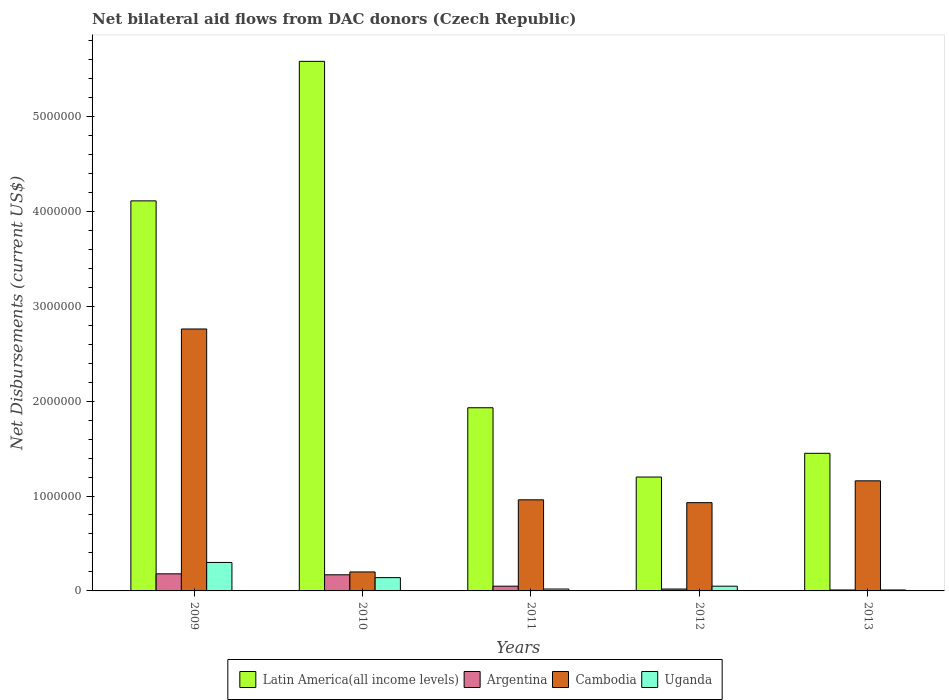How many different coloured bars are there?
Ensure brevity in your answer.  4. Are the number of bars per tick equal to the number of legend labels?
Provide a succinct answer. Yes. How many bars are there on the 5th tick from the right?
Offer a very short reply. 4. What is the label of the 2nd group of bars from the left?
Your response must be concise. 2010. What is the net bilateral aid flows in Argentina in 2011?
Offer a terse response. 5.00e+04. Across all years, what is the maximum net bilateral aid flows in Argentina?
Keep it short and to the point. 1.80e+05. Across all years, what is the minimum net bilateral aid flows in Latin America(all income levels)?
Offer a terse response. 1.20e+06. In which year was the net bilateral aid flows in Uganda maximum?
Make the answer very short. 2009. In which year was the net bilateral aid flows in Uganda minimum?
Ensure brevity in your answer.  2013. What is the total net bilateral aid flows in Cambodia in the graph?
Provide a short and direct response. 6.01e+06. What is the difference between the net bilateral aid flows in Argentina in 2009 and that in 2010?
Your answer should be compact. 10000. What is the difference between the net bilateral aid flows in Uganda in 2011 and the net bilateral aid flows in Cambodia in 2012?
Give a very brief answer. -9.10e+05. What is the average net bilateral aid flows in Argentina per year?
Offer a terse response. 8.60e+04. In the year 2009, what is the difference between the net bilateral aid flows in Uganda and net bilateral aid flows in Latin America(all income levels)?
Keep it short and to the point. -3.81e+06. What is the ratio of the net bilateral aid flows in Cambodia in 2010 to that in 2013?
Your response must be concise. 0.17. Is the net bilateral aid flows in Cambodia in 2011 less than that in 2012?
Keep it short and to the point. No. Is the difference between the net bilateral aid flows in Uganda in 2011 and 2013 greater than the difference between the net bilateral aid flows in Latin America(all income levels) in 2011 and 2013?
Provide a short and direct response. No. What is the difference between the highest and the second highest net bilateral aid flows in Cambodia?
Keep it short and to the point. 1.60e+06. What is the difference between the highest and the lowest net bilateral aid flows in Cambodia?
Provide a succinct answer. 2.56e+06. In how many years, is the net bilateral aid flows in Uganda greater than the average net bilateral aid flows in Uganda taken over all years?
Give a very brief answer. 2. Is it the case that in every year, the sum of the net bilateral aid flows in Uganda and net bilateral aid flows in Cambodia is greater than the sum of net bilateral aid flows in Latin America(all income levels) and net bilateral aid flows in Argentina?
Give a very brief answer. No. What does the 1st bar from the left in 2012 represents?
Offer a terse response. Latin America(all income levels). What does the 2nd bar from the right in 2009 represents?
Your answer should be compact. Cambodia. How many years are there in the graph?
Your answer should be compact. 5. Are the values on the major ticks of Y-axis written in scientific E-notation?
Give a very brief answer. No. Where does the legend appear in the graph?
Your answer should be very brief. Bottom center. How are the legend labels stacked?
Offer a terse response. Horizontal. What is the title of the graph?
Offer a very short reply. Net bilateral aid flows from DAC donors (Czech Republic). What is the label or title of the X-axis?
Make the answer very short. Years. What is the label or title of the Y-axis?
Your answer should be very brief. Net Disbursements (current US$). What is the Net Disbursements (current US$) of Latin America(all income levels) in 2009?
Your answer should be compact. 4.11e+06. What is the Net Disbursements (current US$) of Cambodia in 2009?
Provide a short and direct response. 2.76e+06. What is the Net Disbursements (current US$) in Uganda in 2009?
Offer a terse response. 3.00e+05. What is the Net Disbursements (current US$) of Latin America(all income levels) in 2010?
Make the answer very short. 5.58e+06. What is the Net Disbursements (current US$) of Argentina in 2010?
Offer a terse response. 1.70e+05. What is the Net Disbursements (current US$) in Latin America(all income levels) in 2011?
Give a very brief answer. 1.93e+06. What is the Net Disbursements (current US$) in Cambodia in 2011?
Make the answer very short. 9.60e+05. What is the Net Disbursements (current US$) in Latin America(all income levels) in 2012?
Give a very brief answer. 1.20e+06. What is the Net Disbursements (current US$) in Cambodia in 2012?
Make the answer very short. 9.30e+05. What is the Net Disbursements (current US$) of Uganda in 2012?
Give a very brief answer. 5.00e+04. What is the Net Disbursements (current US$) of Latin America(all income levels) in 2013?
Make the answer very short. 1.45e+06. What is the Net Disbursements (current US$) of Cambodia in 2013?
Make the answer very short. 1.16e+06. What is the Net Disbursements (current US$) in Uganda in 2013?
Make the answer very short. 10000. Across all years, what is the maximum Net Disbursements (current US$) of Latin America(all income levels)?
Provide a succinct answer. 5.58e+06. Across all years, what is the maximum Net Disbursements (current US$) of Argentina?
Offer a terse response. 1.80e+05. Across all years, what is the maximum Net Disbursements (current US$) of Cambodia?
Offer a very short reply. 2.76e+06. Across all years, what is the maximum Net Disbursements (current US$) in Uganda?
Offer a very short reply. 3.00e+05. Across all years, what is the minimum Net Disbursements (current US$) in Latin America(all income levels)?
Offer a very short reply. 1.20e+06. Across all years, what is the minimum Net Disbursements (current US$) in Argentina?
Provide a short and direct response. 10000. Across all years, what is the minimum Net Disbursements (current US$) in Uganda?
Make the answer very short. 10000. What is the total Net Disbursements (current US$) of Latin America(all income levels) in the graph?
Offer a very short reply. 1.43e+07. What is the total Net Disbursements (current US$) of Cambodia in the graph?
Give a very brief answer. 6.01e+06. What is the total Net Disbursements (current US$) in Uganda in the graph?
Your answer should be very brief. 5.20e+05. What is the difference between the Net Disbursements (current US$) in Latin America(all income levels) in 2009 and that in 2010?
Make the answer very short. -1.47e+06. What is the difference between the Net Disbursements (current US$) in Argentina in 2009 and that in 2010?
Make the answer very short. 10000. What is the difference between the Net Disbursements (current US$) in Cambodia in 2009 and that in 2010?
Your response must be concise. 2.56e+06. What is the difference between the Net Disbursements (current US$) in Latin America(all income levels) in 2009 and that in 2011?
Offer a terse response. 2.18e+06. What is the difference between the Net Disbursements (current US$) of Cambodia in 2009 and that in 2011?
Give a very brief answer. 1.80e+06. What is the difference between the Net Disbursements (current US$) in Latin America(all income levels) in 2009 and that in 2012?
Your answer should be very brief. 2.91e+06. What is the difference between the Net Disbursements (current US$) in Cambodia in 2009 and that in 2012?
Offer a very short reply. 1.83e+06. What is the difference between the Net Disbursements (current US$) of Latin America(all income levels) in 2009 and that in 2013?
Your answer should be very brief. 2.66e+06. What is the difference between the Net Disbursements (current US$) in Argentina in 2009 and that in 2013?
Offer a very short reply. 1.70e+05. What is the difference between the Net Disbursements (current US$) in Cambodia in 2009 and that in 2013?
Offer a very short reply. 1.60e+06. What is the difference between the Net Disbursements (current US$) in Uganda in 2009 and that in 2013?
Make the answer very short. 2.90e+05. What is the difference between the Net Disbursements (current US$) of Latin America(all income levels) in 2010 and that in 2011?
Offer a very short reply. 3.65e+06. What is the difference between the Net Disbursements (current US$) in Argentina in 2010 and that in 2011?
Your response must be concise. 1.20e+05. What is the difference between the Net Disbursements (current US$) of Cambodia in 2010 and that in 2011?
Keep it short and to the point. -7.60e+05. What is the difference between the Net Disbursements (current US$) of Uganda in 2010 and that in 2011?
Keep it short and to the point. 1.20e+05. What is the difference between the Net Disbursements (current US$) of Latin America(all income levels) in 2010 and that in 2012?
Give a very brief answer. 4.38e+06. What is the difference between the Net Disbursements (current US$) of Cambodia in 2010 and that in 2012?
Offer a very short reply. -7.30e+05. What is the difference between the Net Disbursements (current US$) in Uganda in 2010 and that in 2012?
Provide a short and direct response. 9.00e+04. What is the difference between the Net Disbursements (current US$) in Latin America(all income levels) in 2010 and that in 2013?
Make the answer very short. 4.13e+06. What is the difference between the Net Disbursements (current US$) in Argentina in 2010 and that in 2013?
Make the answer very short. 1.60e+05. What is the difference between the Net Disbursements (current US$) of Cambodia in 2010 and that in 2013?
Your answer should be very brief. -9.60e+05. What is the difference between the Net Disbursements (current US$) in Latin America(all income levels) in 2011 and that in 2012?
Give a very brief answer. 7.30e+05. What is the difference between the Net Disbursements (current US$) in Cambodia in 2011 and that in 2012?
Keep it short and to the point. 3.00e+04. What is the difference between the Net Disbursements (current US$) of Uganda in 2011 and that in 2012?
Give a very brief answer. -3.00e+04. What is the difference between the Net Disbursements (current US$) in Latin America(all income levels) in 2011 and that in 2013?
Your answer should be very brief. 4.80e+05. What is the difference between the Net Disbursements (current US$) of Cambodia in 2011 and that in 2013?
Give a very brief answer. -2.00e+05. What is the difference between the Net Disbursements (current US$) of Argentina in 2012 and that in 2013?
Give a very brief answer. 10000. What is the difference between the Net Disbursements (current US$) of Uganda in 2012 and that in 2013?
Keep it short and to the point. 4.00e+04. What is the difference between the Net Disbursements (current US$) of Latin America(all income levels) in 2009 and the Net Disbursements (current US$) of Argentina in 2010?
Your response must be concise. 3.94e+06. What is the difference between the Net Disbursements (current US$) of Latin America(all income levels) in 2009 and the Net Disbursements (current US$) of Cambodia in 2010?
Keep it short and to the point. 3.91e+06. What is the difference between the Net Disbursements (current US$) of Latin America(all income levels) in 2009 and the Net Disbursements (current US$) of Uganda in 2010?
Offer a very short reply. 3.97e+06. What is the difference between the Net Disbursements (current US$) in Argentina in 2009 and the Net Disbursements (current US$) in Uganda in 2010?
Provide a short and direct response. 4.00e+04. What is the difference between the Net Disbursements (current US$) in Cambodia in 2009 and the Net Disbursements (current US$) in Uganda in 2010?
Your answer should be very brief. 2.62e+06. What is the difference between the Net Disbursements (current US$) of Latin America(all income levels) in 2009 and the Net Disbursements (current US$) of Argentina in 2011?
Give a very brief answer. 4.06e+06. What is the difference between the Net Disbursements (current US$) in Latin America(all income levels) in 2009 and the Net Disbursements (current US$) in Cambodia in 2011?
Keep it short and to the point. 3.15e+06. What is the difference between the Net Disbursements (current US$) in Latin America(all income levels) in 2009 and the Net Disbursements (current US$) in Uganda in 2011?
Provide a short and direct response. 4.09e+06. What is the difference between the Net Disbursements (current US$) of Argentina in 2009 and the Net Disbursements (current US$) of Cambodia in 2011?
Offer a very short reply. -7.80e+05. What is the difference between the Net Disbursements (current US$) of Argentina in 2009 and the Net Disbursements (current US$) of Uganda in 2011?
Ensure brevity in your answer.  1.60e+05. What is the difference between the Net Disbursements (current US$) of Cambodia in 2009 and the Net Disbursements (current US$) of Uganda in 2011?
Ensure brevity in your answer.  2.74e+06. What is the difference between the Net Disbursements (current US$) of Latin America(all income levels) in 2009 and the Net Disbursements (current US$) of Argentina in 2012?
Give a very brief answer. 4.09e+06. What is the difference between the Net Disbursements (current US$) of Latin America(all income levels) in 2009 and the Net Disbursements (current US$) of Cambodia in 2012?
Provide a succinct answer. 3.18e+06. What is the difference between the Net Disbursements (current US$) in Latin America(all income levels) in 2009 and the Net Disbursements (current US$) in Uganda in 2012?
Offer a terse response. 4.06e+06. What is the difference between the Net Disbursements (current US$) in Argentina in 2009 and the Net Disbursements (current US$) in Cambodia in 2012?
Give a very brief answer. -7.50e+05. What is the difference between the Net Disbursements (current US$) of Argentina in 2009 and the Net Disbursements (current US$) of Uganda in 2012?
Make the answer very short. 1.30e+05. What is the difference between the Net Disbursements (current US$) of Cambodia in 2009 and the Net Disbursements (current US$) of Uganda in 2012?
Offer a terse response. 2.71e+06. What is the difference between the Net Disbursements (current US$) of Latin America(all income levels) in 2009 and the Net Disbursements (current US$) of Argentina in 2013?
Ensure brevity in your answer.  4.10e+06. What is the difference between the Net Disbursements (current US$) of Latin America(all income levels) in 2009 and the Net Disbursements (current US$) of Cambodia in 2013?
Your answer should be very brief. 2.95e+06. What is the difference between the Net Disbursements (current US$) of Latin America(all income levels) in 2009 and the Net Disbursements (current US$) of Uganda in 2013?
Ensure brevity in your answer.  4.10e+06. What is the difference between the Net Disbursements (current US$) of Argentina in 2009 and the Net Disbursements (current US$) of Cambodia in 2013?
Offer a very short reply. -9.80e+05. What is the difference between the Net Disbursements (current US$) in Argentina in 2009 and the Net Disbursements (current US$) in Uganda in 2013?
Give a very brief answer. 1.70e+05. What is the difference between the Net Disbursements (current US$) of Cambodia in 2009 and the Net Disbursements (current US$) of Uganda in 2013?
Keep it short and to the point. 2.75e+06. What is the difference between the Net Disbursements (current US$) in Latin America(all income levels) in 2010 and the Net Disbursements (current US$) in Argentina in 2011?
Offer a very short reply. 5.53e+06. What is the difference between the Net Disbursements (current US$) of Latin America(all income levels) in 2010 and the Net Disbursements (current US$) of Cambodia in 2011?
Provide a short and direct response. 4.62e+06. What is the difference between the Net Disbursements (current US$) in Latin America(all income levels) in 2010 and the Net Disbursements (current US$) in Uganda in 2011?
Your answer should be very brief. 5.56e+06. What is the difference between the Net Disbursements (current US$) in Argentina in 2010 and the Net Disbursements (current US$) in Cambodia in 2011?
Give a very brief answer. -7.90e+05. What is the difference between the Net Disbursements (current US$) of Argentina in 2010 and the Net Disbursements (current US$) of Uganda in 2011?
Provide a short and direct response. 1.50e+05. What is the difference between the Net Disbursements (current US$) in Cambodia in 2010 and the Net Disbursements (current US$) in Uganda in 2011?
Provide a short and direct response. 1.80e+05. What is the difference between the Net Disbursements (current US$) of Latin America(all income levels) in 2010 and the Net Disbursements (current US$) of Argentina in 2012?
Offer a terse response. 5.56e+06. What is the difference between the Net Disbursements (current US$) in Latin America(all income levels) in 2010 and the Net Disbursements (current US$) in Cambodia in 2012?
Provide a short and direct response. 4.65e+06. What is the difference between the Net Disbursements (current US$) in Latin America(all income levels) in 2010 and the Net Disbursements (current US$) in Uganda in 2012?
Provide a short and direct response. 5.53e+06. What is the difference between the Net Disbursements (current US$) of Argentina in 2010 and the Net Disbursements (current US$) of Cambodia in 2012?
Your answer should be very brief. -7.60e+05. What is the difference between the Net Disbursements (current US$) in Latin America(all income levels) in 2010 and the Net Disbursements (current US$) in Argentina in 2013?
Ensure brevity in your answer.  5.57e+06. What is the difference between the Net Disbursements (current US$) of Latin America(all income levels) in 2010 and the Net Disbursements (current US$) of Cambodia in 2013?
Provide a succinct answer. 4.42e+06. What is the difference between the Net Disbursements (current US$) of Latin America(all income levels) in 2010 and the Net Disbursements (current US$) of Uganda in 2013?
Provide a succinct answer. 5.57e+06. What is the difference between the Net Disbursements (current US$) of Argentina in 2010 and the Net Disbursements (current US$) of Cambodia in 2013?
Your answer should be compact. -9.90e+05. What is the difference between the Net Disbursements (current US$) of Argentina in 2010 and the Net Disbursements (current US$) of Uganda in 2013?
Make the answer very short. 1.60e+05. What is the difference between the Net Disbursements (current US$) of Latin America(all income levels) in 2011 and the Net Disbursements (current US$) of Argentina in 2012?
Your answer should be compact. 1.91e+06. What is the difference between the Net Disbursements (current US$) of Latin America(all income levels) in 2011 and the Net Disbursements (current US$) of Cambodia in 2012?
Keep it short and to the point. 1.00e+06. What is the difference between the Net Disbursements (current US$) in Latin America(all income levels) in 2011 and the Net Disbursements (current US$) in Uganda in 2012?
Offer a very short reply. 1.88e+06. What is the difference between the Net Disbursements (current US$) of Argentina in 2011 and the Net Disbursements (current US$) of Cambodia in 2012?
Your answer should be compact. -8.80e+05. What is the difference between the Net Disbursements (current US$) of Cambodia in 2011 and the Net Disbursements (current US$) of Uganda in 2012?
Offer a terse response. 9.10e+05. What is the difference between the Net Disbursements (current US$) in Latin America(all income levels) in 2011 and the Net Disbursements (current US$) in Argentina in 2013?
Offer a terse response. 1.92e+06. What is the difference between the Net Disbursements (current US$) of Latin America(all income levels) in 2011 and the Net Disbursements (current US$) of Cambodia in 2013?
Offer a terse response. 7.70e+05. What is the difference between the Net Disbursements (current US$) in Latin America(all income levels) in 2011 and the Net Disbursements (current US$) in Uganda in 2013?
Provide a succinct answer. 1.92e+06. What is the difference between the Net Disbursements (current US$) in Argentina in 2011 and the Net Disbursements (current US$) in Cambodia in 2013?
Provide a short and direct response. -1.11e+06. What is the difference between the Net Disbursements (current US$) in Cambodia in 2011 and the Net Disbursements (current US$) in Uganda in 2013?
Offer a terse response. 9.50e+05. What is the difference between the Net Disbursements (current US$) in Latin America(all income levels) in 2012 and the Net Disbursements (current US$) in Argentina in 2013?
Offer a very short reply. 1.19e+06. What is the difference between the Net Disbursements (current US$) in Latin America(all income levels) in 2012 and the Net Disbursements (current US$) in Cambodia in 2013?
Your response must be concise. 4.00e+04. What is the difference between the Net Disbursements (current US$) in Latin America(all income levels) in 2012 and the Net Disbursements (current US$) in Uganda in 2013?
Offer a terse response. 1.19e+06. What is the difference between the Net Disbursements (current US$) in Argentina in 2012 and the Net Disbursements (current US$) in Cambodia in 2013?
Offer a very short reply. -1.14e+06. What is the difference between the Net Disbursements (current US$) of Cambodia in 2012 and the Net Disbursements (current US$) of Uganda in 2013?
Provide a succinct answer. 9.20e+05. What is the average Net Disbursements (current US$) in Latin America(all income levels) per year?
Provide a short and direct response. 2.85e+06. What is the average Net Disbursements (current US$) of Argentina per year?
Give a very brief answer. 8.60e+04. What is the average Net Disbursements (current US$) of Cambodia per year?
Give a very brief answer. 1.20e+06. What is the average Net Disbursements (current US$) of Uganda per year?
Keep it short and to the point. 1.04e+05. In the year 2009, what is the difference between the Net Disbursements (current US$) in Latin America(all income levels) and Net Disbursements (current US$) in Argentina?
Give a very brief answer. 3.93e+06. In the year 2009, what is the difference between the Net Disbursements (current US$) of Latin America(all income levels) and Net Disbursements (current US$) of Cambodia?
Your response must be concise. 1.35e+06. In the year 2009, what is the difference between the Net Disbursements (current US$) of Latin America(all income levels) and Net Disbursements (current US$) of Uganda?
Provide a short and direct response. 3.81e+06. In the year 2009, what is the difference between the Net Disbursements (current US$) in Argentina and Net Disbursements (current US$) in Cambodia?
Offer a terse response. -2.58e+06. In the year 2009, what is the difference between the Net Disbursements (current US$) of Argentina and Net Disbursements (current US$) of Uganda?
Keep it short and to the point. -1.20e+05. In the year 2009, what is the difference between the Net Disbursements (current US$) in Cambodia and Net Disbursements (current US$) in Uganda?
Offer a very short reply. 2.46e+06. In the year 2010, what is the difference between the Net Disbursements (current US$) in Latin America(all income levels) and Net Disbursements (current US$) in Argentina?
Offer a very short reply. 5.41e+06. In the year 2010, what is the difference between the Net Disbursements (current US$) of Latin America(all income levels) and Net Disbursements (current US$) of Cambodia?
Make the answer very short. 5.38e+06. In the year 2010, what is the difference between the Net Disbursements (current US$) of Latin America(all income levels) and Net Disbursements (current US$) of Uganda?
Provide a short and direct response. 5.44e+06. In the year 2010, what is the difference between the Net Disbursements (current US$) in Argentina and Net Disbursements (current US$) in Cambodia?
Offer a very short reply. -3.00e+04. In the year 2010, what is the difference between the Net Disbursements (current US$) in Argentina and Net Disbursements (current US$) in Uganda?
Your answer should be compact. 3.00e+04. In the year 2011, what is the difference between the Net Disbursements (current US$) in Latin America(all income levels) and Net Disbursements (current US$) in Argentina?
Offer a terse response. 1.88e+06. In the year 2011, what is the difference between the Net Disbursements (current US$) in Latin America(all income levels) and Net Disbursements (current US$) in Cambodia?
Your answer should be very brief. 9.70e+05. In the year 2011, what is the difference between the Net Disbursements (current US$) of Latin America(all income levels) and Net Disbursements (current US$) of Uganda?
Your answer should be compact. 1.91e+06. In the year 2011, what is the difference between the Net Disbursements (current US$) of Argentina and Net Disbursements (current US$) of Cambodia?
Keep it short and to the point. -9.10e+05. In the year 2011, what is the difference between the Net Disbursements (current US$) of Cambodia and Net Disbursements (current US$) of Uganda?
Make the answer very short. 9.40e+05. In the year 2012, what is the difference between the Net Disbursements (current US$) of Latin America(all income levels) and Net Disbursements (current US$) of Argentina?
Give a very brief answer. 1.18e+06. In the year 2012, what is the difference between the Net Disbursements (current US$) of Latin America(all income levels) and Net Disbursements (current US$) of Uganda?
Your answer should be compact. 1.15e+06. In the year 2012, what is the difference between the Net Disbursements (current US$) in Argentina and Net Disbursements (current US$) in Cambodia?
Offer a terse response. -9.10e+05. In the year 2012, what is the difference between the Net Disbursements (current US$) in Cambodia and Net Disbursements (current US$) in Uganda?
Your answer should be very brief. 8.80e+05. In the year 2013, what is the difference between the Net Disbursements (current US$) in Latin America(all income levels) and Net Disbursements (current US$) in Argentina?
Give a very brief answer. 1.44e+06. In the year 2013, what is the difference between the Net Disbursements (current US$) in Latin America(all income levels) and Net Disbursements (current US$) in Uganda?
Make the answer very short. 1.44e+06. In the year 2013, what is the difference between the Net Disbursements (current US$) in Argentina and Net Disbursements (current US$) in Cambodia?
Keep it short and to the point. -1.15e+06. In the year 2013, what is the difference between the Net Disbursements (current US$) in Argentina and Net Disbursements (current US$) in Uganda?
Offer a very short reply. 0. In the year 2013, what is the difference between the Net Disbursements (current US$) of Cambodia and Net Disbursements (current US$) of Uganda?
Provide a succinct answer. 1.15e+06. What is the ratio of the Net Disbursements (current US$) of Latin America(all income levels) in 2009 to that in 2010?
Make the answer very short. 0.74. What is the ratio of the Net Disbursements (current US$) in Argentina in 2009 to that in 2010?
Ensure brevity in your answer.  1.06. What is the ratio of the Net Disbursements (current US$) of Uganda in 2009 to that in 2010?
Keep it short and to the point. 2.14. What is the ratio of the Net Disbursements (current US$) in Latin America(all income levels) in 2009 to that in 2011?
Offer a terse response. 2.13. What is the ratio of the Net Disbursements (current US$) of Argentina in 2009 to that in 2011?
Your answer should be very brief. 3.6. What is the ratio of the Net Disbursements (current US$) in Cambodia in 2009 to that in 2011?
Keep it short and to the point. 2.88. What is the ratio of the Net Disbursements (current US$) of Latin America(all income levels) in 2009 to that in 2012?
Keep it short and to the point. 3.42. What is the ratio of the Net Disbursements (current US$) in Argentina in 2009 to that in 2012?
Your answer should be compact. 9. What is the ratio of the Net Disbursements (current US$) of Cambodia in 2009 to that in 2012?
Offer a terse response. 2.97. What is the ratio of the Net Disbursements (current US$) of Uganda in 2009 to that in 2012?
Your response must be concise. 6. What is the ratio of the Net Disbursements (current US$) of Latin America(all income levels) in 2009 to that in 2013?
Provide a short and direct response. 2.83. What is the ratio of the Net Disbursements (current US$) of Argentina in 2009 to that in 2013?
Your response must be concise. 18. What is the ratio of the Net Disbursements (current US$) of Cambodia in 2009 to that in 2013?
Give a very brief answer. 2.38. What is the ratio of the Net Disbursements (current US$) in Latin America(all income levels) in 2010 to that in 2011?
Your answer should be very brief. 2.89. What is the ratio of the Net Disbursements (current US$) in Cambodia in 2010 to that in 2011?
Offer a terse response. 0.21. What is the ratio of the Net Disbursements (current US$) in Uganda in 2010 to that in 2011?
Give a very brief answer. 7. What is the ratio of the Net Disbursements (current US$) of Latin America(all income levels) in 2010 to that in 2012?
Your answer should be compact. 4.65. What is the ratio of the Net Disbursements (current US$) of Argentina in 2010 to that in 2012?
Give a very brief answer. 8.5. What is the ratio of the Net Disbursements (current US$) of Cambodia in 2010 to that in 2012?
Your answer should be very brief. 0.22. What is the ratio of the Net Disbursements (current US$) of Uganda in 2010 to that in 2012?
Offer a terse response. 2.8. What is the ratio of the Net Disbursements (current US$) of Latin America(all income levels) in 2010 to that in 2013?
Your answer should be compact. 3.85. What is the ratio of the Net Disbursements (current US$) in Cambodia in 2010 to that in 2013?
Offer a terse response. 0.17. What is the ratio of the Net Disbursements (current US$) in Uganda in 2010 to that in 2013?
Provide a short and direct response. 14. What is the ratio of the Net Disbursements (current US$) of Latin America(all income levels) in 2011 to that in 2012?
Provide a succinct answer. 1.61. What is the ratio of the Net Disbursements (current US$) in Cambodia in 2011 to that in 2012?
Give a very brief answer. 1.03. What is the ratio of the Net Disbursements (current US$) of Latin America(all income levels) in 2011 to that in 2013?
Provide a short and direct response. 1.33. What is the ratio of the Net Disbursements (current US$) of Cambodia in 2011 to that in 2013?
Provide a succinct answer. 0.83. What is the ratio of the Net Disbursements (current US$) of Latin America(all income levels) in 2012 to that in 2013?
Ensure brevity in your answer.  0.83. What is the ratio of the Net Disbursements (current US$) of Argentina in 2012 to that in 2013?
Keep it short and to the point. 2. What is the ratio of the Net Disbursements (current US$) of Cambodia in 2012 to that in 2013?
Your response must be concise. 0.8. What is the difference between the highest and the second highest Net Disbursements (current US$) in Latin America(all income levels)?
Offer a terse response. 1.47e+06. What is the difference between the highest and the second highest Net Disbursements (current US$) of Argentina?
Ensure brevity in your answer.  10000. What is the difference between the highest and the second highest Net Disbursements (current US$) of Cambodia?
Make the answer very short. 1.60e+06. What is the difference between the highest and the lowest Net Disbursements (current US$) in Latin America(all income levels)?
Your answer should be compact. 4.38e+06. What is the difference between the highest and the lowest Net Disbursements (current US$) in Cambodia?
Offer a terse response. 2.56e+06. 